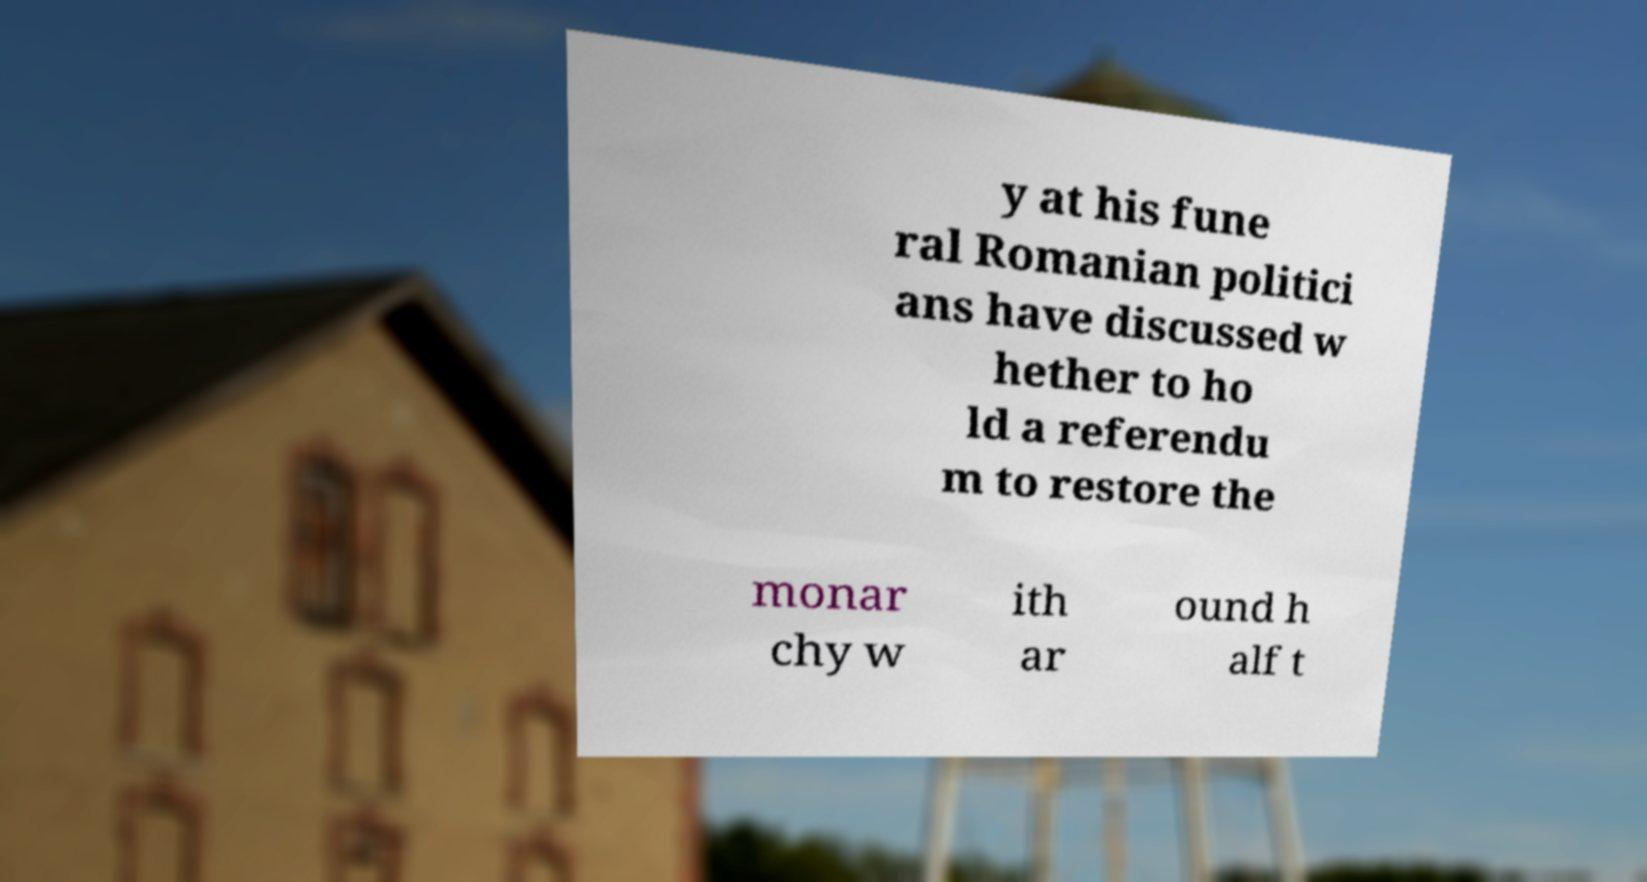There's text embedded in this image that I need extracted. Can you transcribe it verbatim? y at his fune ral Romanian politici ans have discussed w hether to ho ld a referendu m to restore the monar chy w ith ar ound h alf t 